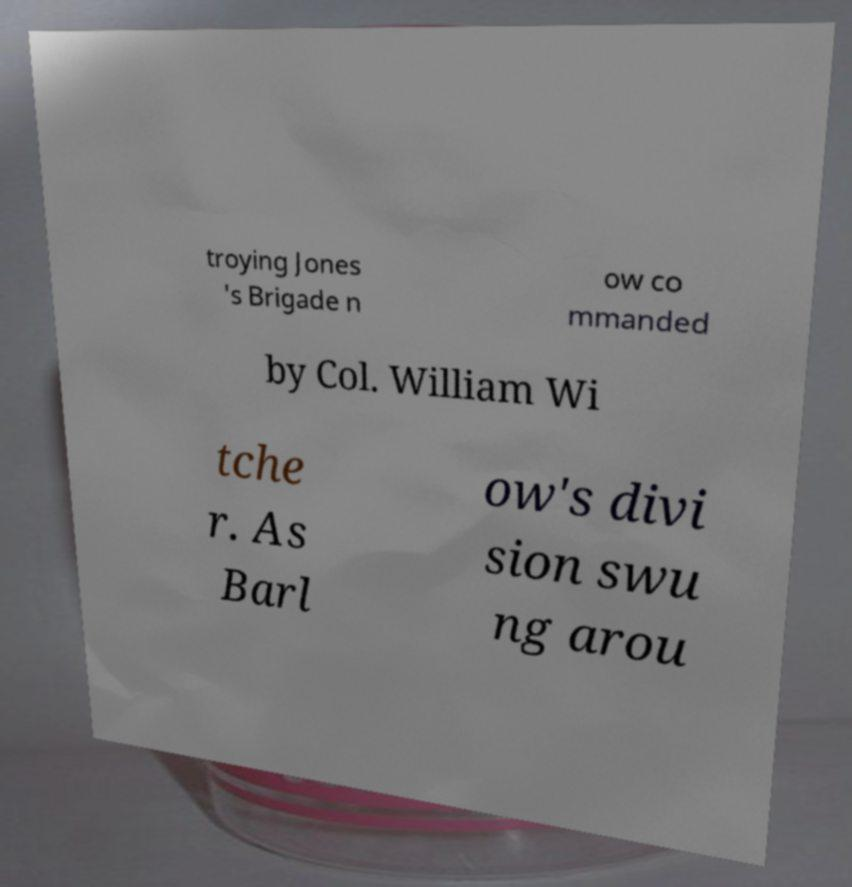Please read and relay the text visible in this image. What does it say? troying Jones 's Brigade n ow co mmanded by Col. William Wi tche r. As Barl ow's divi sion swu ng arou 